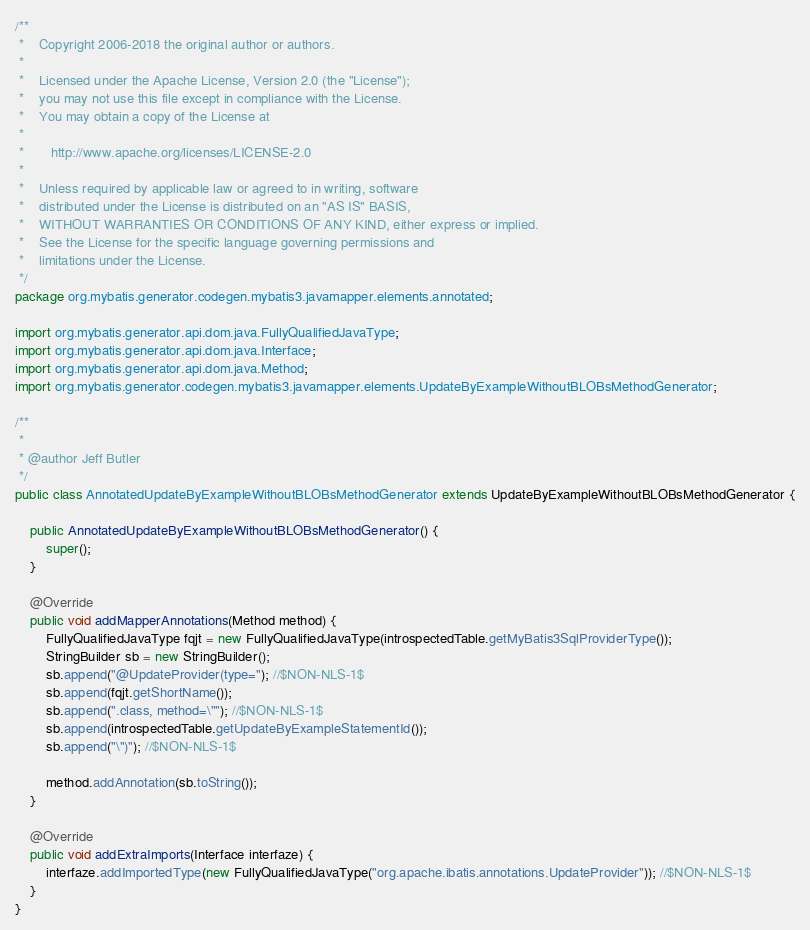Convert code to text. <code><loc_0><loc_0><loc_500><loc_500><_Java_>/**
 *    Copyright 2006-2018 the original author or authors.
 *
 *    Licensed under the Apache License, Version 2.0 (the "License");
 *    you may not use this file except in compliance with the License.
 *    You may obtain a copy of the License at
 *
 *       http://www.apache.org/licenses/LICENSE-2.0
 *
 *    Unless required by applicable law or agreed to in writing, software
 *    distributed under the License is distributed on an "AS IS" BASIS,
 *    WITHOUT WARRANTIES OR CONDITIONS OF ANY KIND, either express or implied.
 *    See the License for the specific language governing permissions and
 *    limitations under the License.
 */
package org.mybatis.generator.codegen.mybatis3.javamapper.elements.annotated;

import org.mybatis.generator.api.dom.java.FullyQualifiedJavaType;
import org.mybatis.generator.api.dom.java.Interface;
import org.mybatis.generator.api.dom.java.Method;
import org.mybatis.generator.codegen.mybatis3.javamapper.elements.UpdateByExampleWithoutBLOBsMethodGenerator;

/**
 * 
 * @author Jeff Butler
 */
public class AnnotatedUpdateByExampleWithoutBLOBsMethodGenerator extends UpdateByExampleWithoutBLOBsMethodGenerator {

    public AnnotatedUpdateByExampleWithoutBLOBsMethodGenerator() {
        super();
    }

    @Override
    public void addMapperAnnotations(Method method) {
        FullyQualifiedJavaType fqjt = new FullyQualifiedJavaType(introspectedTable.getMyBatis3SqlProviderType());
        StringBuilder sb = new StringBuilder();
        sb.append("@UpdateProvider(type="); //$NON-NLS-1$
        sb.append(fqjt.getShortName());
        sb.append(".class, method=\""); //$NON-NLS-1$
        sb.append(introspectedTable.getUpdateByExampleStatementId());
        sb.append("\")"); //$NON-NLS-1$

        method.addAnnotation(sb.toString());
    }

    @Override
    public void addExtraImports(Interface interfaze) {
        interfaze.addImportedType(new FullyQualifiedJavaType("org.apache.ibatis.annotations.UpdateProvider")); //$NON-NLS-1$
    }
}
</code> 